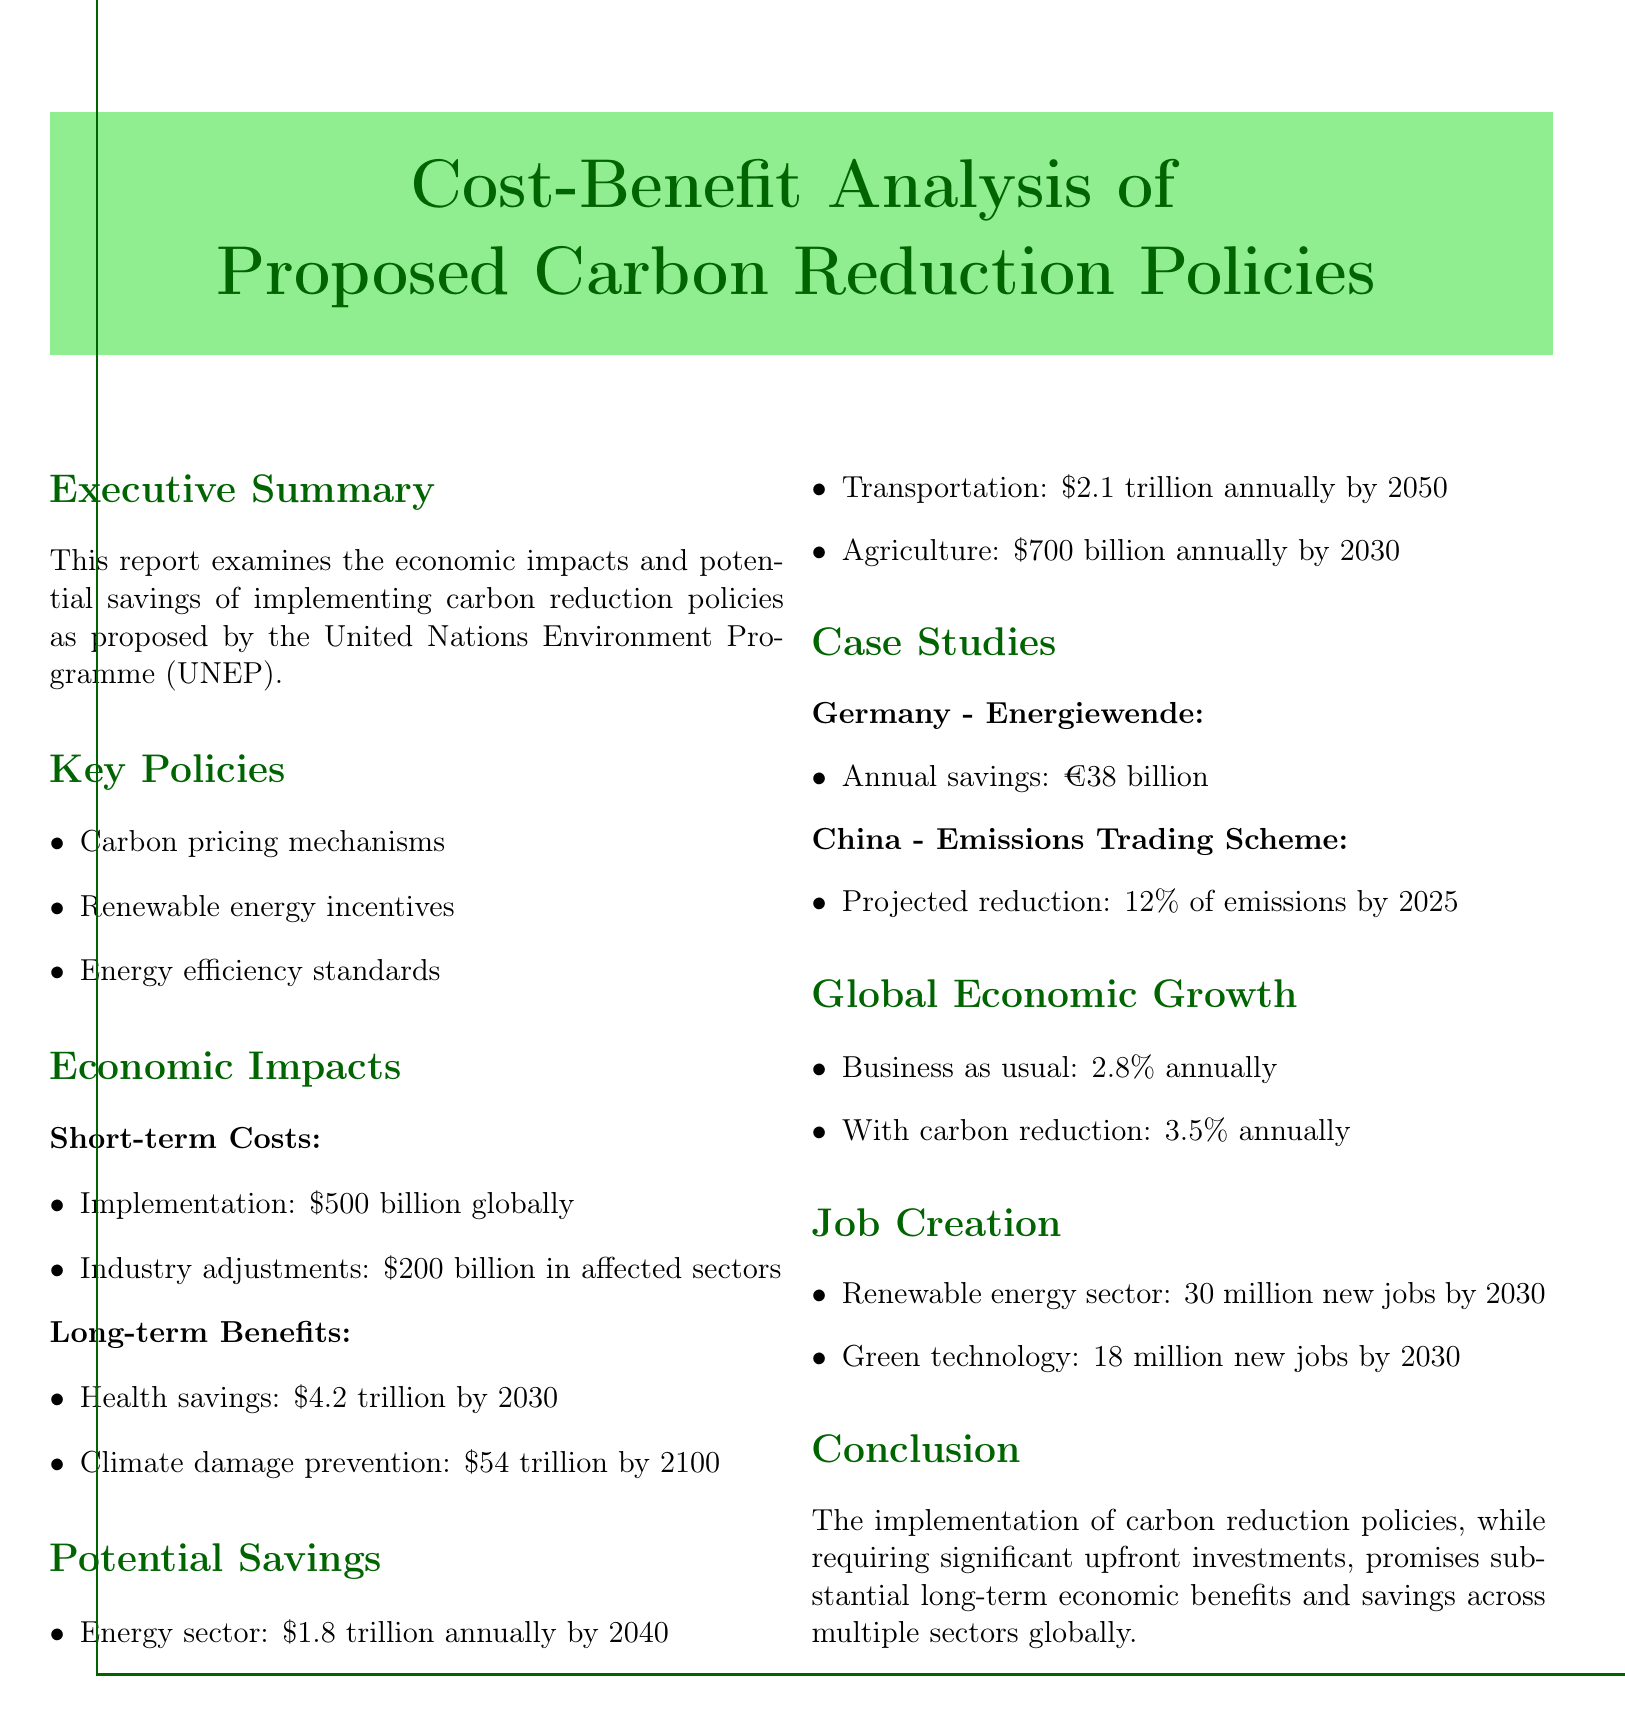What is the title of the report? The title of the report is stated at the beginning and indicates the focus of the document on cost-benefit analysis regarding carbon reduction policies.
Answer: Cost-Benefit Analysis of Proposed Carbon Reduction Policies What is the total short-term cost for implementation globally? The document specifies the short-term costs, detailing the total amount required for implementation of carbon reduction policies.
Answer: $500 billion globally What is the estimated health savings by 2030? The long-term benefits section lists the projected health savings from implementing carbon reduction policies by the year 2030.
Answer: $4.2 trillion by 2030 How many new jobs are projected to be created in the renewable energy sector by 2030? The job creation section of the document outlines the anticipated employment growth in the renewable energy sector as a result of carbon reduction policies.
Answer: 30 million new jobs by 2030 What percentage of emissions is China projected to reduce by 2025? The case study detailing China's policy includes a specific target for emissions reduction, allowing for a straightforward response.
Answer: 12% of emissions by 2025 What is the projected annual saving in the agriculture sector by 2030? The potential savings section of the report includes specific financial figures related to various sectors, including agriculture.
Answer: $700 billion annually by 2030 What is the difference in global economic growth between business as usual and with carbon reduction? The document provides comparative figures on projected economic growth under different scenarios, leading to a deductive question regarding the difference.
Answer: 0.7% annually What is the annual saving attributed to Germany's Energiewende policy? The case study on Germany highlights its specific financial savings from its carbon reduction approach, which can be directly quoted.
Answer: €38 billion How much is projected to be saved annually in the transportation sector by 2050? The potential savings section lists expected savings across various sectors by specific years, including transportation.
Answer: $2.1 trillion annually by 2050 